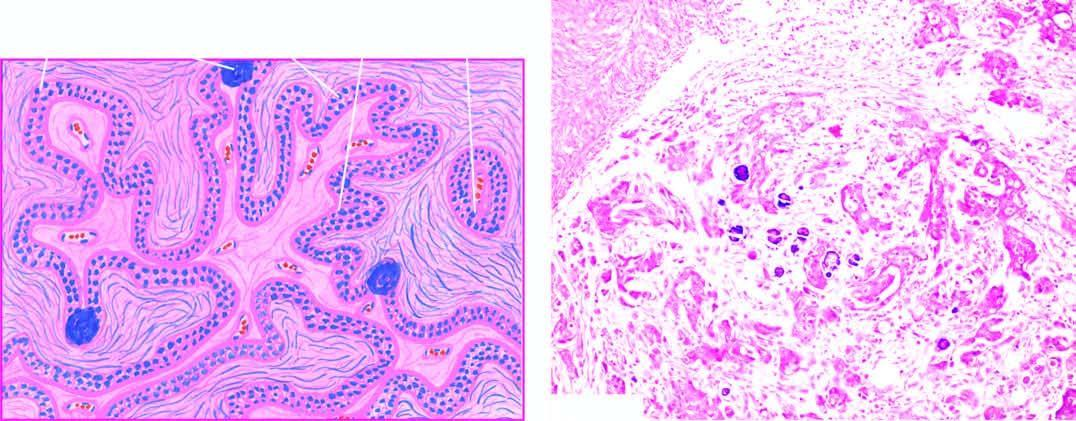what shows invasion by clusters of anaplastic tumour cells?
Answer the question using a single word or phrase. Stroma 